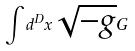<formula> <loc_0><loc_0><loc_500><loc_500>\int d ^ { D } x \sqrt { - g } G</formula> 